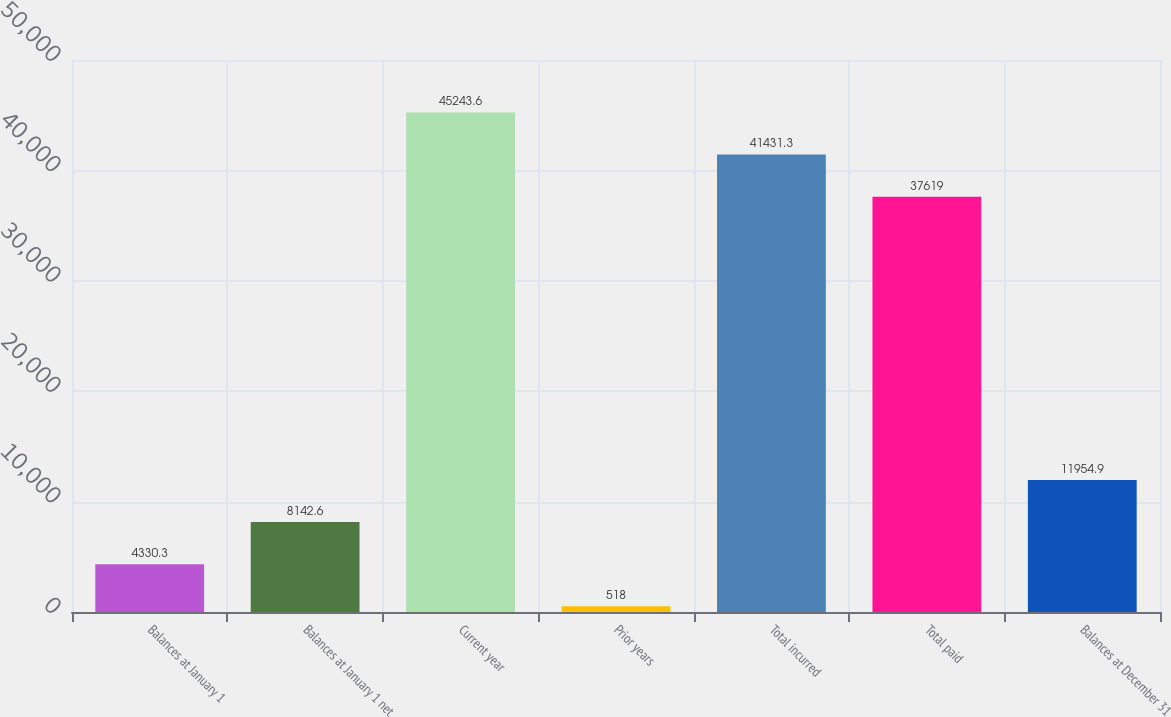<chart> <loc_0><loc_0><loc_500><loc_500><bar_chart><fcel>Balances at January 1<fcel>Balances at January 1 net<fcel>Current year<fcel>Prior years<fcel>Total incurred<fcel>Total paid<fcel>Balances at December 31<nl><fcel>4330.3<fcel>8142.6<fcel>45243.6<fcel>518<fcel>41431.3<fcel>37619<fcel>11954.9<nl></chart> 